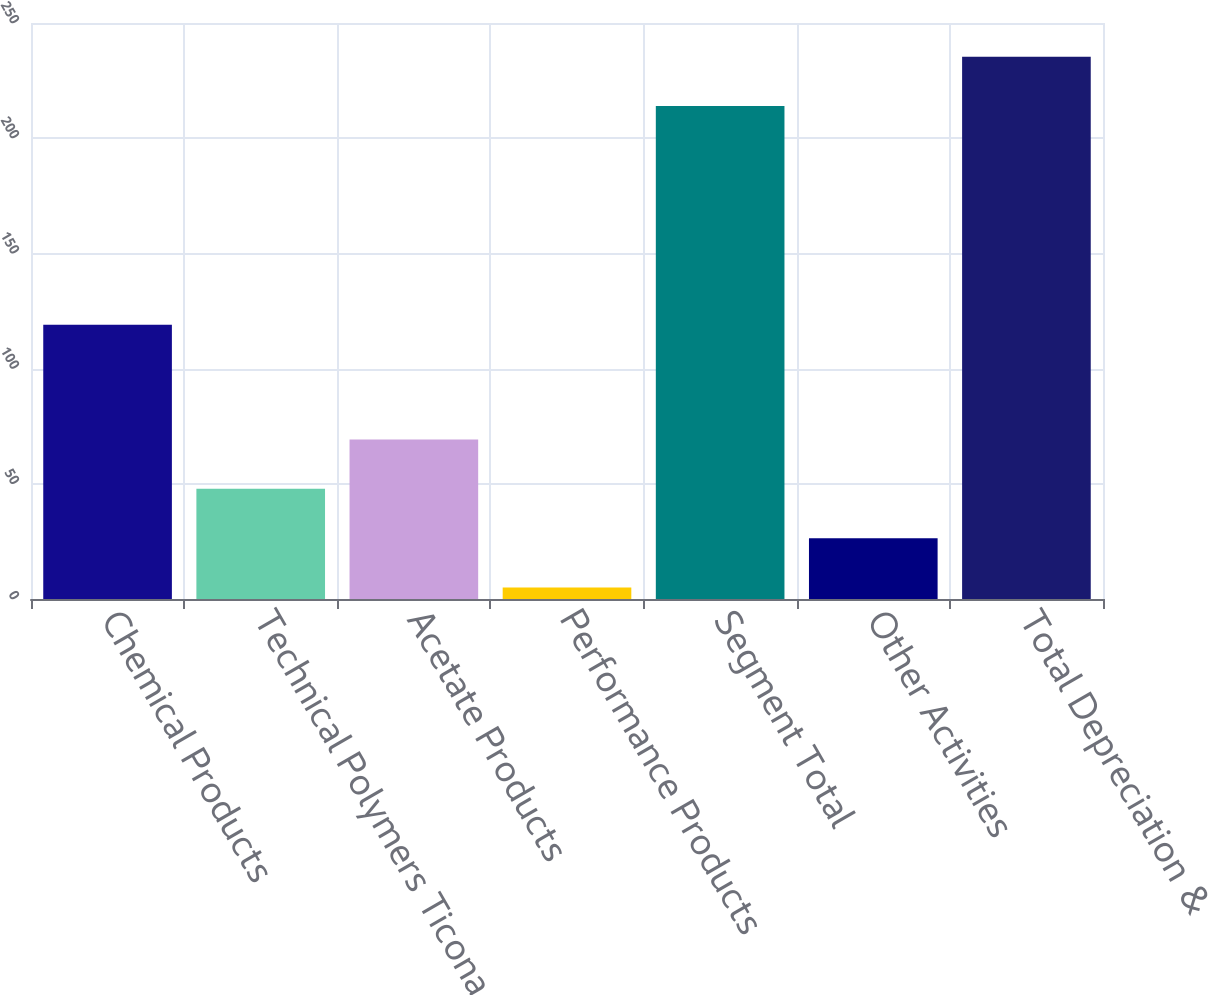<chart> <loc_0><loc_0><loc_500><loc_500><bar_chart><fcel>Chemical Products<fcel>Technical Polymers Ticona<fcel>Acetate Products<fcel>Performance Products<fcel>Segment Total<fcel>Other Activities<fcel>Total Depreciation &<nl><fcel>119<fcel>47.8<fcel>69.2<fcel>5<fcel>214<fcel>26.4<fcel>235.4<nl></chart> 